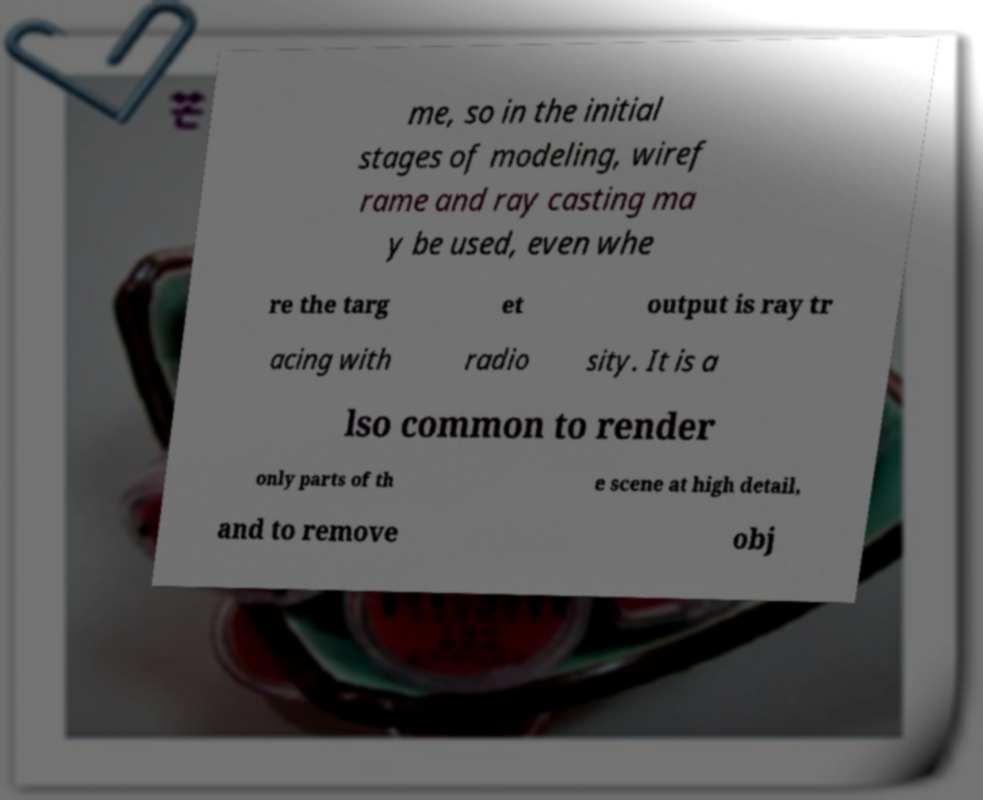Could you extract and type out the text from this image? me, so in the initial stages of modeling, wiref rame and ray casting ma y be used, even whe re the targ et output is ray tr acing with radio sity. It is a lso common to render only parts of th e scene at high detail, and to remove obj 